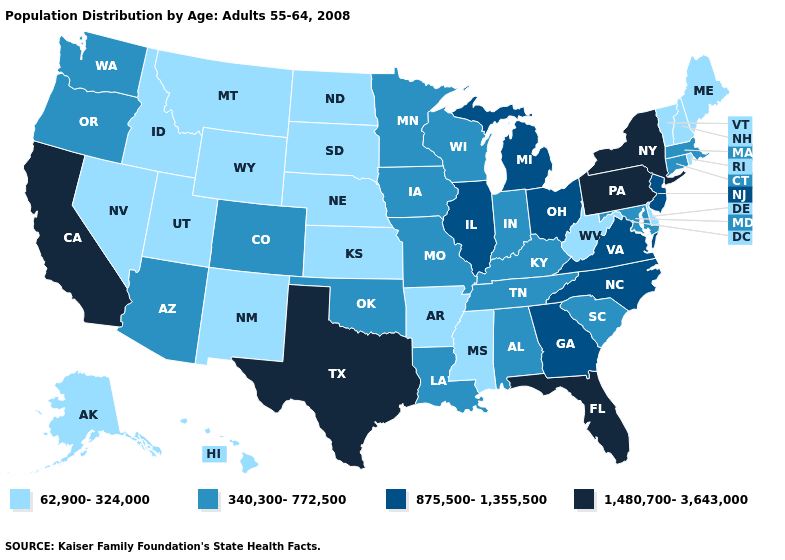What is the value of South Carolina?
Write a very short answer. 340,300-772,500. Name the states that have a value in the range 62,900-324,000?
Concise answer only. Alaska, Arkansas, Delaware, Hawaii, Idaho, Kansas, Maine, Mississippi, Montana, Nebraska, Nevada, New Hampshire, New Mexico, North Dakota, Rhode Island, South Dakota, Utah, Vermont, West Virginia, Wyoming. Does Pennsylvania have the highest value in the Northeast?
Keep it brief. Yes. What is the highest value in the Northeast ?
Give a very brief answer. 1,480,700-3,643,000. Among the states that border New Jersey , which have the highest value?
Write a very short answer. New York, Pennsylvania. Does New York have the highest value in the USA?
Be succinct. Yes. Does the map have missing data?
Short answer required. No. Which states have the highest value in the USA?
Write a very short answer. California, Florida, New York, Pennsylvania, Texas. What is the value of North Carolina?
Concise answer only. 875,500-1,355,500. Does Washington have the lowest value in the West?
Quick response, please. No. Which states have the lowest value in the Northeast?
Quick response, please. Maine, New Hampshire, Rhode Island, Vermont. Does the map have missing data?
Be succinct. No. What is the value of Michigan?
Concise answer only. 875,500-1,355,500. Among the states that border West Virginia , does Kentucky have the lowest value?
Be succinct. Yes. Does Nevada have the same value as West Virginia?
Be succinct. Yes. 